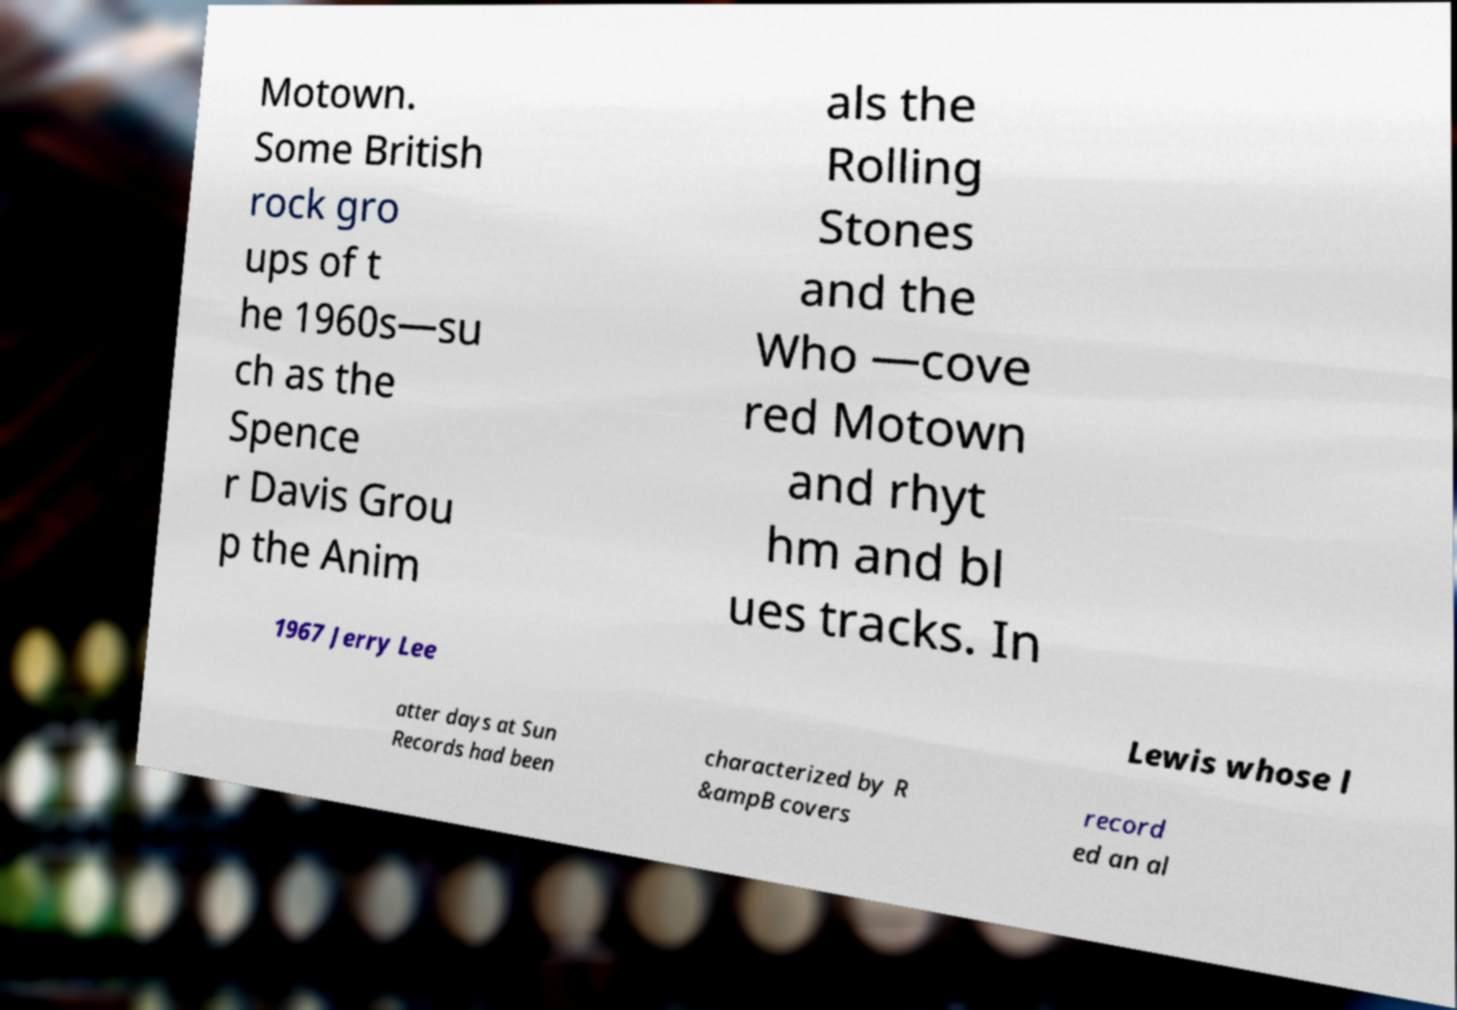Please identify and transcribe the text found in this image. Motown. Some British rock gro ups of t he 1960s—su ch as the Spence r Davis Grou p the Anim als the Rolling Stones and the Who —cove red Motown and rhyt hm and bl ues tracks. In 1967 Jerry Lee Lewis whose l atter days at Sun Records had been characterized by R &ampB covers record ed an al 